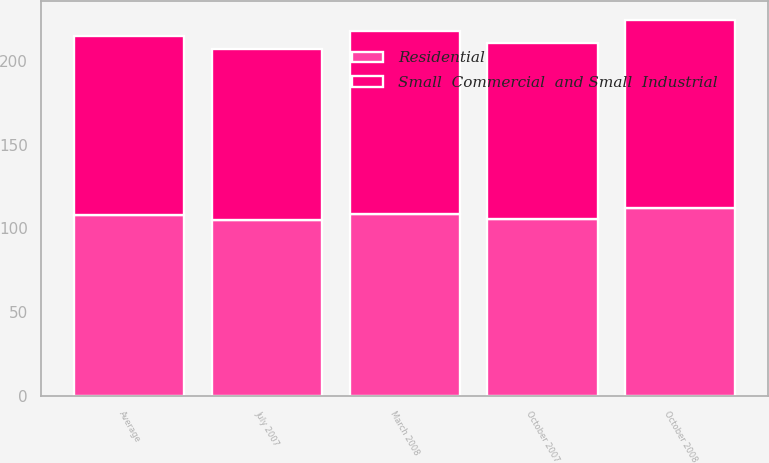Convert chart. <chart><loc_0><loc_0><loc_500><loc_500><stacked_bar_chart><ecel><fcel>July 2007<fcel>October 2007<fcel>March 2008<fcel>October 2008<fcel>Average<nl><fcel>Small  Commercial  and Small  Industrial<fcel>101.77<fcel>105.08<fcel>108.8<fcel>112.51<fcel>107.04<nl><fcel>Residential<fcel>105.11<fcel>105.75<fcel>108.76<fcel>111.94<fcel>107.89<nl></chart> 